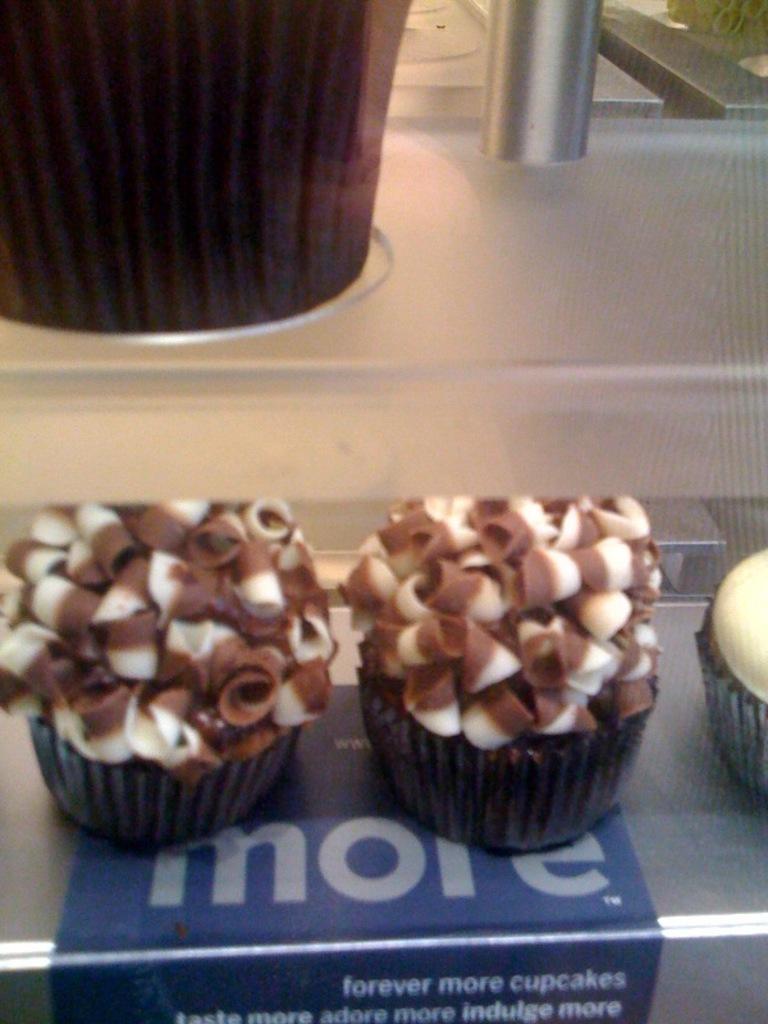Describe this image in one or two sentences. In the image we can see a table, on the table there are some cupcakes. 